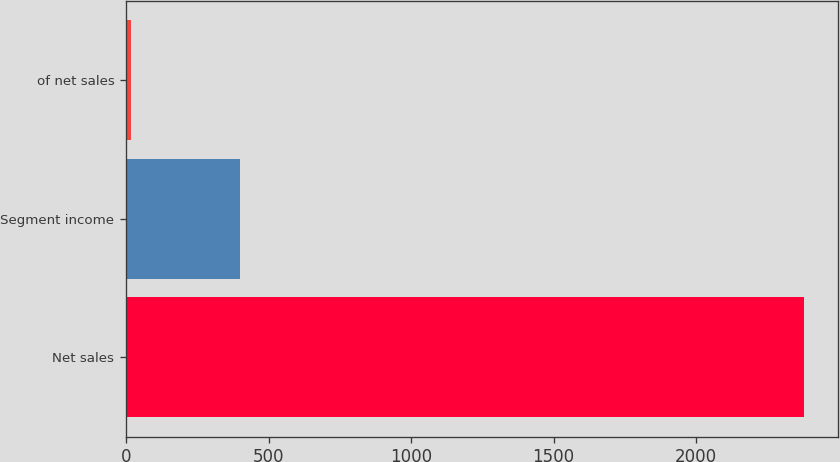Convert chart to OTSL. <chart><loc_0><loc_0><loc_500><loc_500><bar_chart><fcel>Net sales<fcel>Segment income<fcel>of net sales<nl><fcel>2377.3<fcel>398.5<fcel>16.8<nl></chart> 